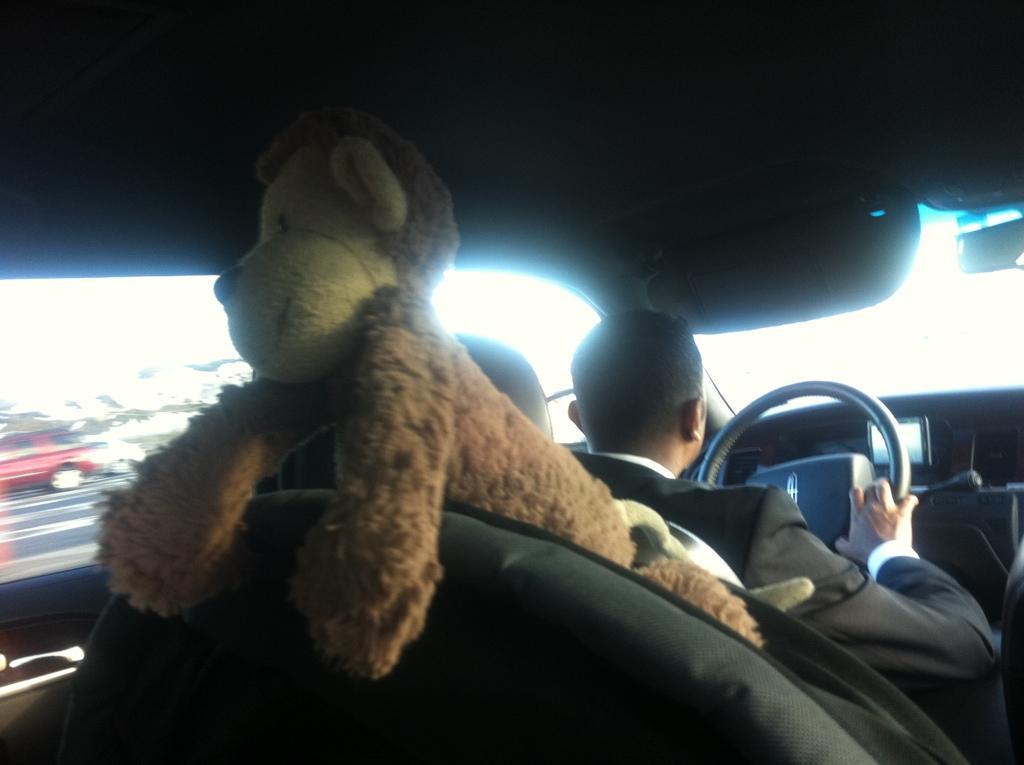Could you give a brief overview of what you see in this image? In the picture we can see inside a car there is a man driving a car. In the back side we can see a bag and a doll. From a inside the car we can see out side there are vehicles on the road. 